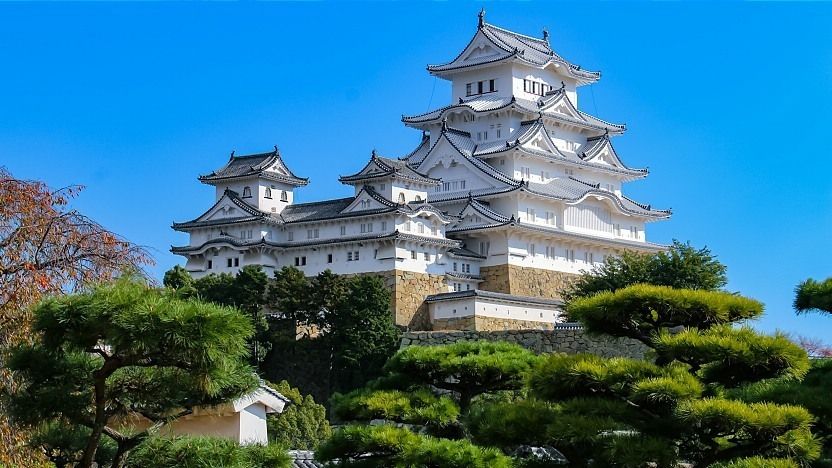How might this castle appear during a traditional Japanese festival? During a traditional Japanese festival, Himeji Castle would transform into a vibrant and lively center of cultural celebration. The castle grounds and surrounding areas would be adorned with colorful lanterns and streamers, creating a festive atmosphere. The sound of taiko drums and traditional music would resonate through the air, inviting people to partake in the festivities. Stalls offering street food, crafts, and games would be set up, attracting visitors from far and wide. The night would come alive with fireworks, illuminating the castle's white facade and creating a dazzling display against the night sky. Traditional dances, performances, and possibly even a sharegpt4v/samurai reenactment would take place, celebrating the rich cultural heritage of Japan and the historical significance of Himeji Castle. Pretend you are a poet standing in front of this castle. Write a haiku inspired by the scene. White heron stands tall,
Guard of history's whispers,
Beneath autumn skies. 